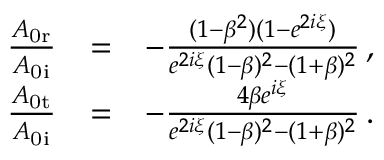<formula> <loc_0><loc_0><loc_500><loc_500>\begin{array} { r l r } { \frac { A _ { 0 r } } { A _ { 0 i } } } & { = } & { - \frac { ( 1 - \beta ^ { 2 } ) ( 1 - e ^ { 2 i \xi } ) } { e ^ { 2 i \xi } ( 1 - \beta ) ^ { 2 } - ( 1 + \beta ) ^ { 2 } } \, , } \\ { \frac { A _ { 0 t } } { A _ { 0 i } } } & { = } & { - \frac { 4 \beta e ^ { i \xi } } { e ^ { 2 i \xi } ( 1 - \beta ) ^ { 2 } - ( 1 + \beta ) ^ { 2 } } \, . } \end{array}</formula> 